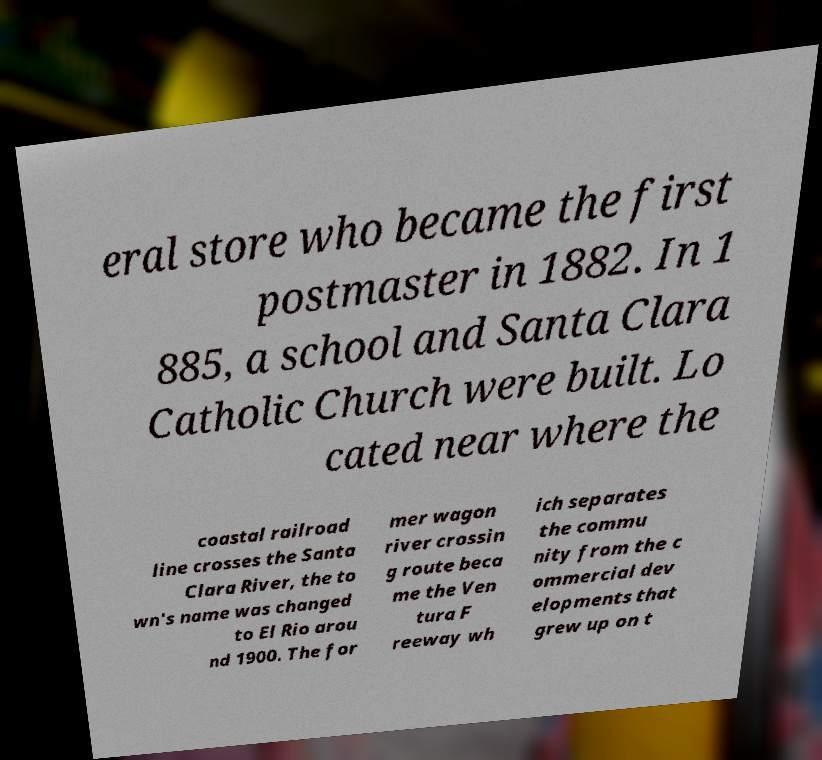Please read and relay the text visible in this image. What does it say? eral store who became the first postmaster in 1882. In 1 885, a school and Santa Clara Catholic Church were built. Lo cated near where the coastal railroad line crosses the Santa Clara River, the to wn's name was changed to El Rio arou nd 1900. The for mer wagon river crossin g route beca me the Ven tura F reeway wh ich separates the commu nity from the c ommercial dev elopments that grew up on t 